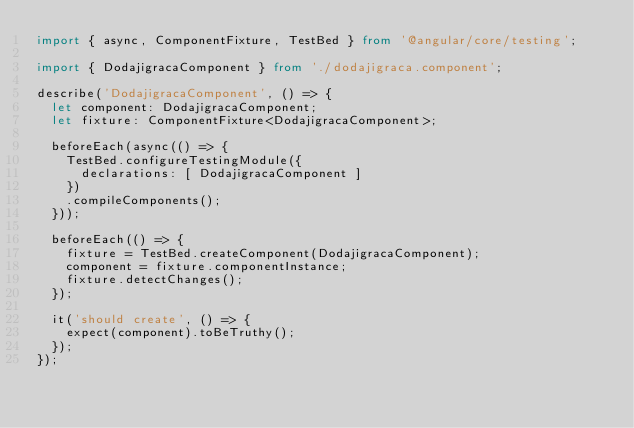<code> <loc_0><loc_0><loc_500><loc_500><_TypeScript_>import { async, ComponentFixture, TestBed } from '@angular/core/testing';

import { DodajigracaComponent } from './dodajigraca.component';

describe('DodajigracaComponent', () => {
  let component: DodajigracaComponent;
  let fixture: ComponentFixture<DodajigracaComponent>;

  beforeEach(async(() => {
    TestBed.configureTestingModule({
      declarations: [ DodajigracaComponent ]
    })
    .compileComponents();
  }));

  beforeEach(() => {
    fixture = TestBed.createComponent(DodajigracaComponent);
    component = fixture.componentInstance;
    fixture.detectChanges();
  });

  it('should create', () => {
    expect(component).toBeTruthy();
  });
});
</code> 